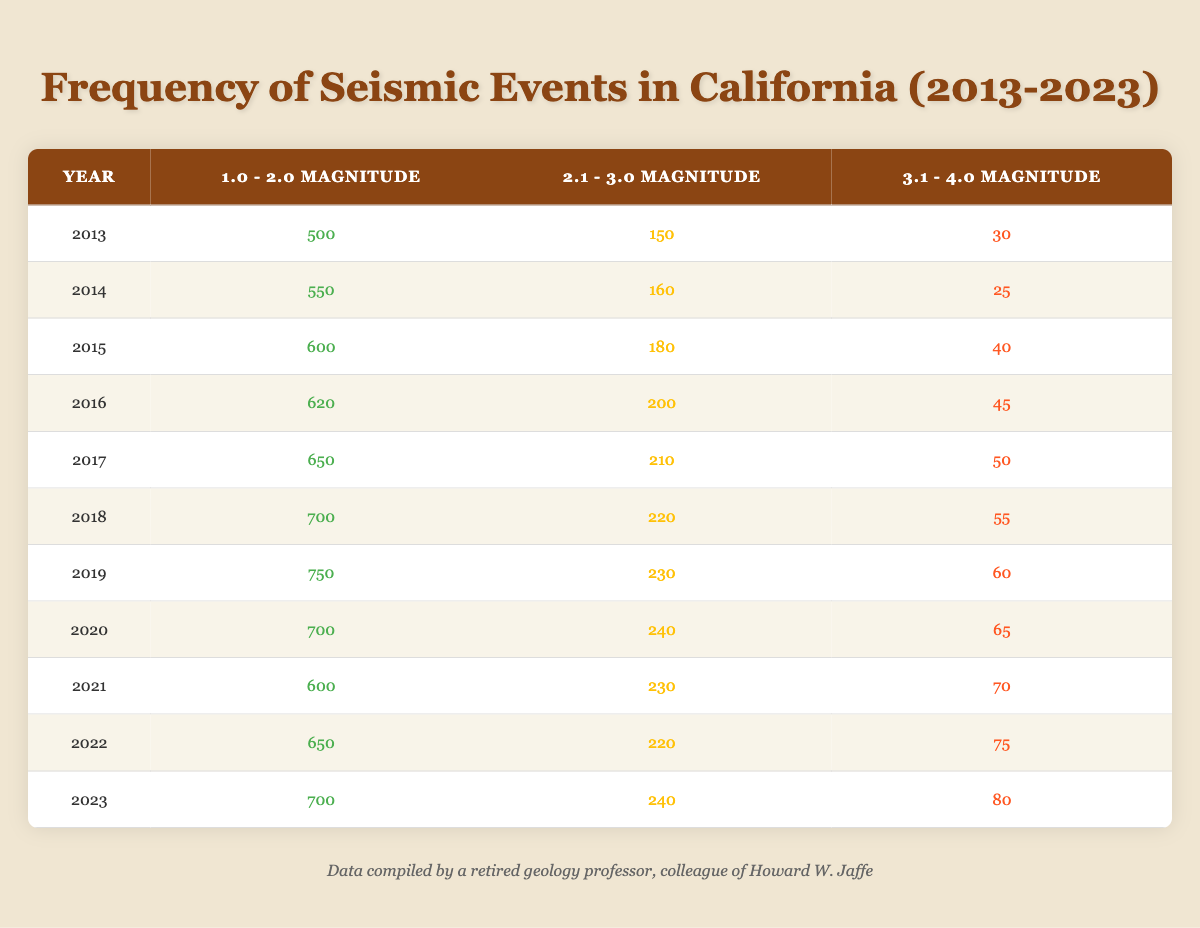What was the event count for seismic events with a magnitude of 2.1 - 3.0 in 2019? In the table, when looking at the year 2019, the corresponding value for the magnitude range of 2.1 - 3.0 is 230.
Answer: 230 What was the maximum number of seismic events recorded in the magnitude range of 1.0 - 2.0? By scanning through the "1.0 - 2.0 Magnitude" column, the maximum value is 750, which occurs in 2019.
Answer: 750 Which year had the highest count of seismic events in the magnitude range of 3.1 - 4.0? Looking at the "3.1 - 4.0 Magnitude" column, the highest count of events is 80, which is recorded in 2023.
Answer: 2023 How many seismic events in the magnitude range of 1.0 - 2.0 were recorded from 2013 to 2023? Summing the values from the "1.0 - 2.0 Magnitude" column gives: 500 + 550 + 600 + 620 + 650 + 700 + 750 + 700 + 600 + 650 + 700 = 7,450.
Answer: 7450 Did the number of seismic events in the magnitude range of 3.1 - 4.0 see an overall increase or decrease during the past decade? Analyzing the "3.1 - 4.0 Magnitude" column from 2013 to 2023, we see the following counts: 30, 25, 40, 45, 50, 55, 60, 65, 70, 75, 80. The values are steadily increasing.
Answer: Increase What is the average event count in the magnitude range of 2.1 - 3.0 for the years 2021 and 2022? For 2021, the count is 230, and for 2022, it is 220. To find the average, we sum these values (230 + 220 = 450) and divide by 2, resulting in an average of 225.
Answer: 225 In which year was the count of seismic events in the magnitude range of 2.1 - 3.0 less than 200? By inspecting the "2.1 - 3.0 Magnitude" column for each year, the only year with a count below 200 is 2013, which has 150.
Answer: 2013 How many more seismic events were recorded in the magnitude range of 1.0 - 2.0 than in the range of 3.1 - 4.0 in 2023? For the year 2023, the count in the "1.0 - 2.0 Magnitude" is 700 and in the "3.1 - 4.0 Magnitude" it is 80. The difference is calculated as 700 - 80 = 620.
Answer: 620 